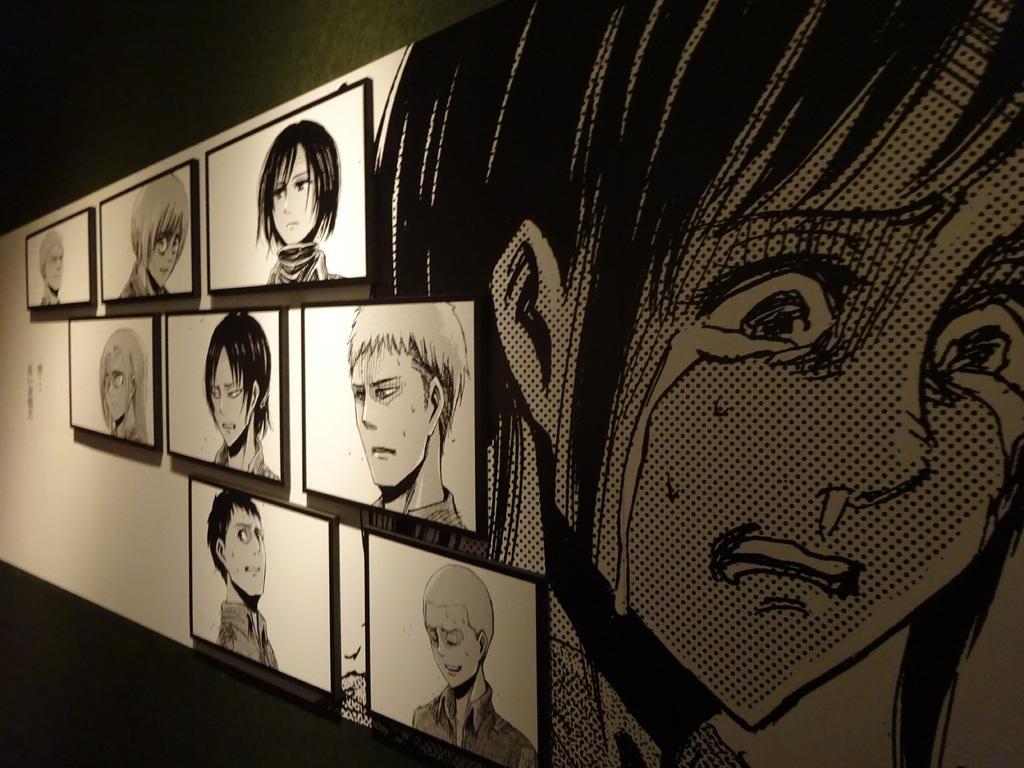Describe this image in one or two sentences. In the image I can see the pictures of some cartoons to the wall. 